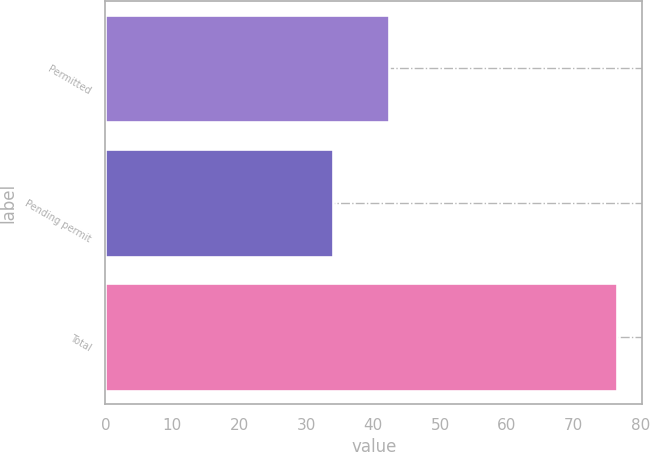Convert chart. <chart><loc_0><loc_0><loc_500><loc_500><bar_chart><fcel>Permitted<fcel>Pending permit<fcel>Total<nl><fcel>42.4<fcel>34<fcel>76.4<nl></chart> 